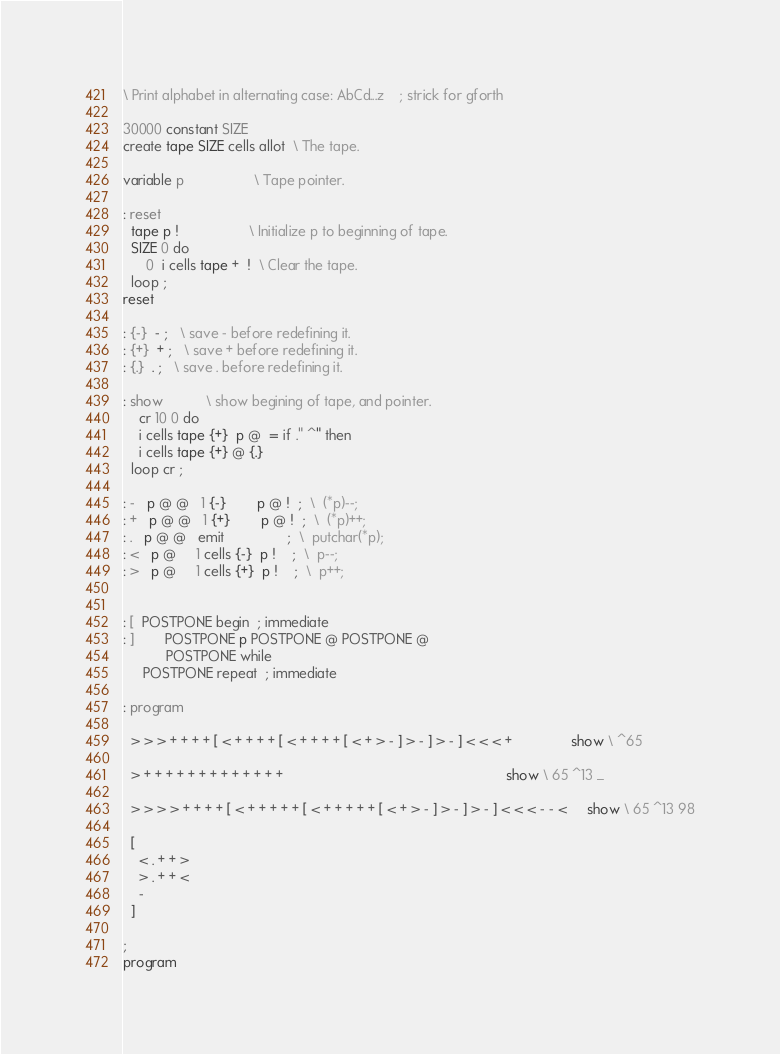<code> <loc_0><loc_0><loc_500><loc_500><_Forth_>\ Print alphabet in alternating case: AbCd...z    ; strick for gforth

30000 constant SIZE
create tape SIZE cells allot  \ The tape.

variable p                  \ Tape pointer.

: reset
  tape p !                  \ Initialize p to beginning of tape.
  SIZE 0 do
      0  i cells tape +  !  \ Clear the tape.
  loop ;
reset

: {-}  - ;   \ save - before redefining it.
: {+}  + ;   \ save + before redefining it.
: {.}  . ;   \ save . before redefining it.

: show           \ show begining of tape, and pointer.
    cr 10 0 do
    i cells tape {+}  p @  = if ." ^" then
    i cells tape {+} @ {.}
  loop cr ;

: -   p @ @   1 {-}        p @ !  ;  \  (*p)--;
: +   p @ @   1 {+}        p @ !  ;  \  (*p)++;
: .   p @ @   emit                ;  \  putchar(*p);
: <   p @     1 cells {-}  p !    ;  \  p--;
: >   p @     1 cells {+}  p !    ;  \  p++;


: [  POSTPONE begin  ; immediate
: ]        POSTPONE p POSTPONE @ POSTPONE @  
           POSTPONE while  
     POSTPONE repeat  ; immediate

: program

  > > > + + + + [ < + + + + [ < + + + + [ < + > - ] > - ] > - ] < < < +               show \ ^65

  > + + + + + + + + + + + + +                                                         show \ 65 ^13 _

  > > > > + + + + [ < + + + + + [ < + + + + + [ < + > - ] > - ] > - ] < < < - - <     show \ 65 ^13 98

  [
    < . + + >
    > . + + <
    -
  ]

;
program
</code> 